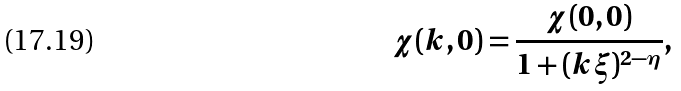<formula> <loc_0><loc_0><loc_500><loc_500>\chi ( { k } , 0 ) = \frac { \chi ( 0 , 0 ) } { 1 + ( { k } \xi ) ^ { 2 - \eta } } ,</formula> 